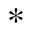Convert formula to latex. <formula><loc_0><loc_0><loc_500><loc_500>^ { * }</formula> 